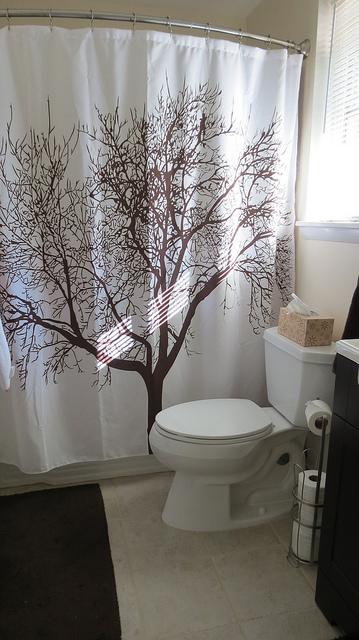Where is the window?
Answer briefly. Above toilet. What is on the shower curtain?
Short answer required. Tree. Is there any toilet paper?
Answer briefly. Yes. 